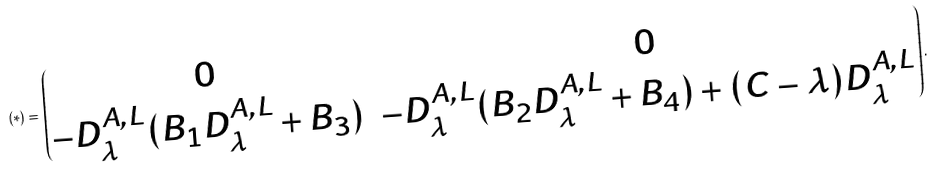<formula> <loc_0><loc_0><loc_500><loc_500>( * ) = \begin{pmatrix} 0 & 0 \\ - D _ { \lambda } ^ { A , L } ( B _ { 1 } D _ { \lambda } ^ { A , L } + B _ { 3 } ) & - D _ { \lambda } ^ { A , L } ( B _ { 2 } D _ { \lambda } ^ { A , L } + B _ { 4 } ) + ( C - \lambda ) D _ { \lambda } ^ { A , L } \end{pmatrix} .</formula> 